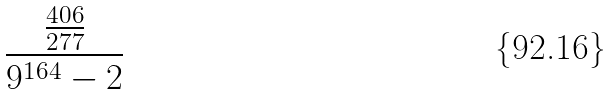Convert formula to latex. <formula><loc_0><loc_0><loc_500><loc_500>\frac { \frac { 4 0 6 } { 2 7 7 } } { 9 ^ { 1 6 4 } - 2 }</formula> 